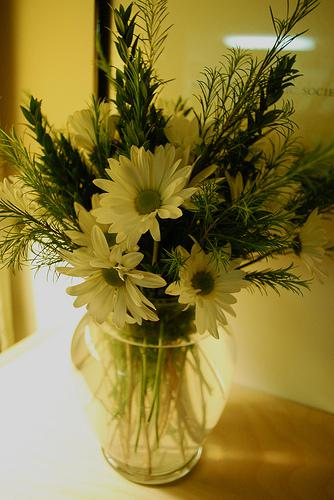Question: why is water in the vase?
Choices:
A. To keep flowers fresh.
B. To feed the flowers.
C. To weight the vase down.
D. To keep the vase clean.
Answer with the letter. Answer: A Question: who arranged the flowers?
Choices:
A. A employee.
B. A florist.
C. A store manager.
D. The owner.
Answer with the letter. Answer: B Question: where is green foliage?
Choices:
A. In a garden.
B. In a forest.
C. In a park.
D. With the daisies.
Answer with the letter. Answer: D Question: what is the vase on?
Choices:
A. A countertop.
B. On the floor.
C. On a shelf.
D. A table.
Answer with the letter. Answer: D 